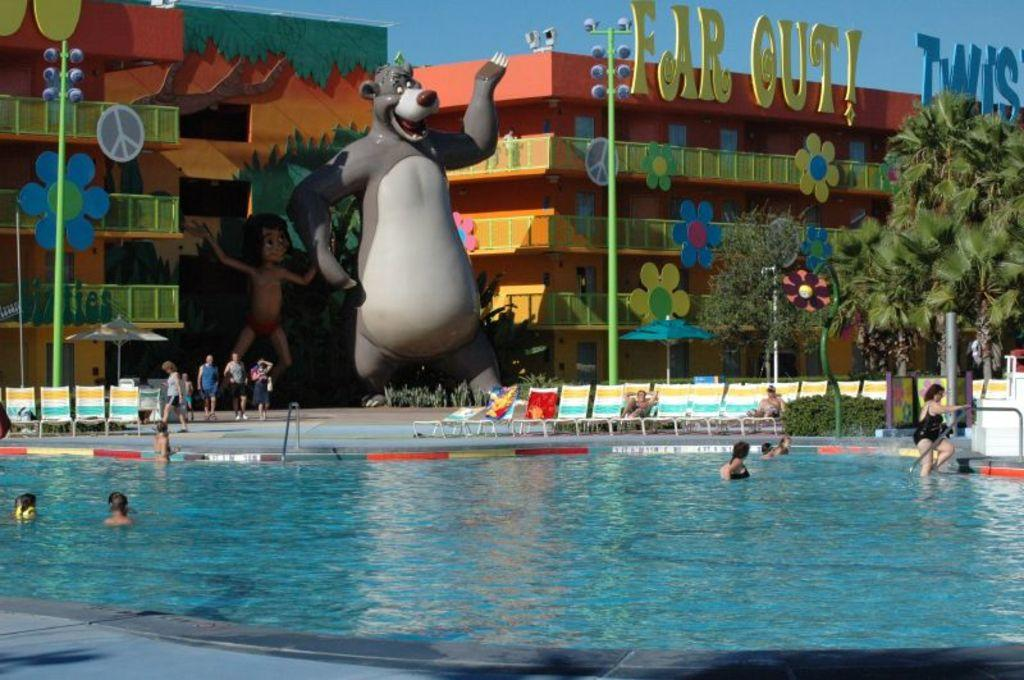What is the main feature of the image? There is a swimming pool in the image. What color is the water in the swimming pool? The water in the swimming pool is blue. Are there any people in the image? Yes, there are people in the swimming pool. What can be seen in the distance in the image? There are cartoons and poles visible in the distance. Can you tell me how many berries are floating in the swimming pool? There are no berries visible in the swimming pool; it only contains water. What type of horn is being used by the people in the swimming pool? There is no horn present in the image; the people's sister doing in the image? 